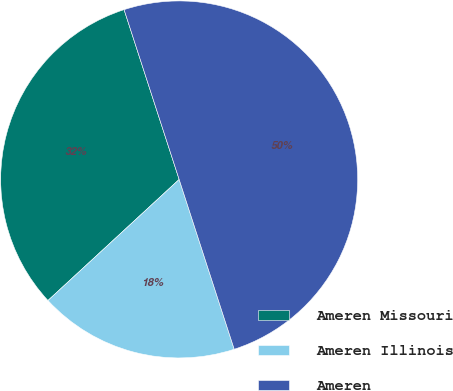<chart> <loc_0><loc_0><loc_500><loc_500><pie_chart><fcel>Ameren Missouri<fcel>Ameren Illinois<fcel>Ameren<nl><fcel>31.87%<fcel>18.13%<fcel>50.0%<nl></chart> 